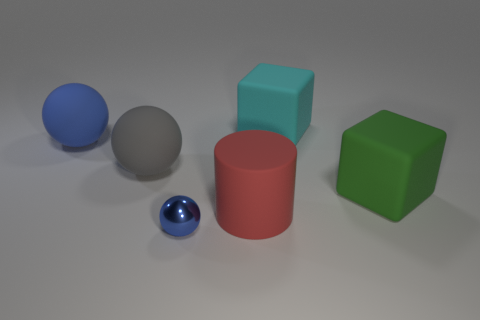Add 2 gray shiny spheres. How many objects exist? 8 Subtract all tiny shiny spheres. How many spheres are left? 2 Subtract all cubes. How many objects are left? 4 Subtract 2 blocks. How many blocks are left? 0 Subtract all yellow cylinders. Subtract all green cubes. How many cylinders are left? 1 Subtract all gray cylinders. How many gray cubes are left? 0 Subtract all matte cylinders. Subtract all small brown rubber things. How many objects are left? 5 Add 5 big matte blocks. How many big matte blocks are left? 7 Add 1 big green objects. How many big green objects exist? 2 Subtract all blue spheres. How many spheres are left? 1 